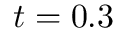Convert formula to latex. <formula><loc_0><loc_0><loc_500><loc_500>t = 0 . 3</formula> 